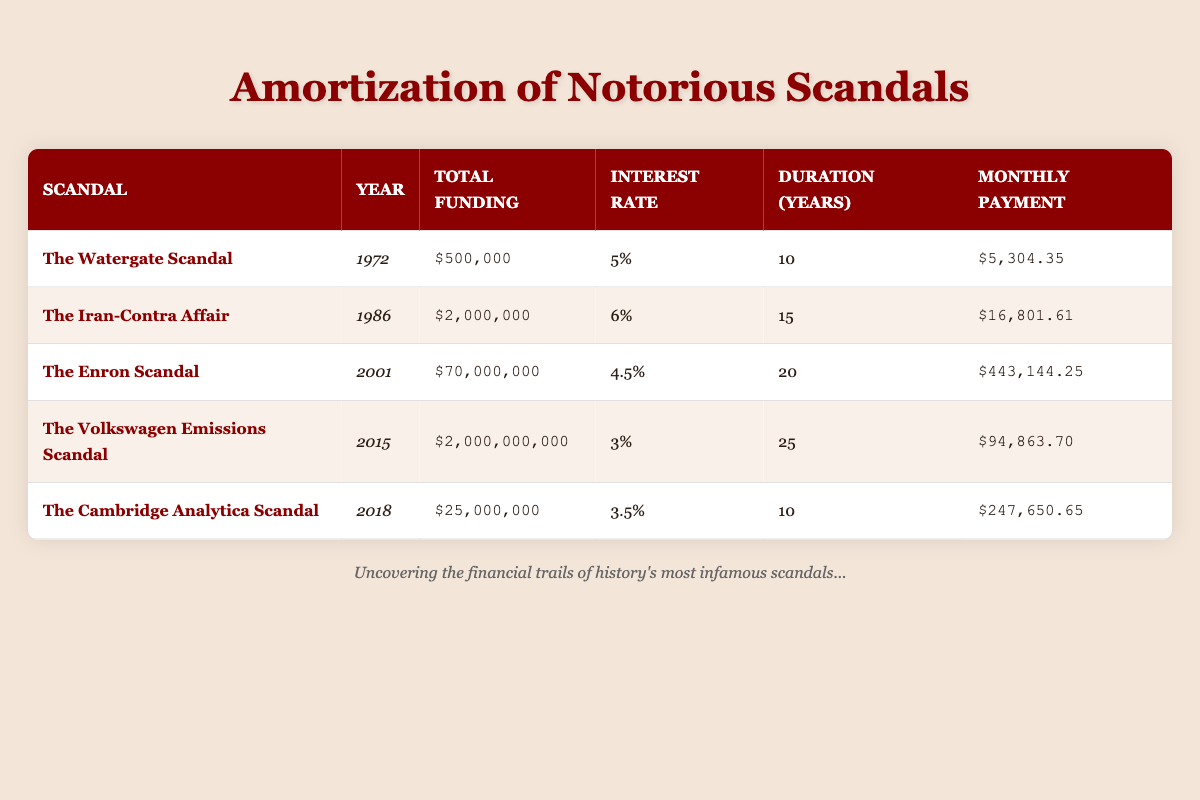What is the total funding for The Iran-Contra Affair? The table lists the total funding for The Iran-Contra Affair under the corresponding column, which shows $2,000,000.
Answer: 2,000,000 What is the interest rate for The Volkswagen Emissions Scandal? Referring to the table, the interest rate for The Volkswagen Emissions Scandal is specified as 3%.
Answer: 3% How much is the monthly payment for the Enron Scandal? The monthly payment listed for the Enron Scandal in the table is $443,144.25.
Answer: 443,144.25 Which scandal had the longest duration for repayment? By comparing the duration columns, The Volkswagen Emissions Scandal had the longest duration for repayment, which is 25 years.
Answer: The Volkswagen Emissions Scandal What is the average total funding of all scandals listed? First, sum the total funding amounts from all scandals: $500,000 + $2,000,000 + $70,000,000 + $2,000,000,000 + $25,000,000 = $2,097,500,000. Then, divide by the number of scandals (5): $2,097,500,000 / 5 = $419,500,000.
Answer: 419,500,000 Is the interest rate for The Cambridge Analytica Scandal higher than 4%? The table shows that the interest rate for The Cambridge Analytica Scandal is 3.5%, which is less than 4%. Thus, the answer is no.
Answer: No What is the difference in monthly payments between The Watergate Scandal and The Iran-Contra Affair? The monthly payment for The Watergate Scandal is $5,304.35, and for The Iran-Contra Affair, it is $16,801.61. To find the difference: $16,801.61 - $5,304.35 = $11,497.26.
Answer: 11,497.26 Which scandal has a total funding greater than $1 billion? The table indicates that The Volkswagen Emissions Scandal has a total funding of $2,000,000,000, exceeding $1 billion.
Answer: Yes How many scandals occurred after the year 2000? The scandals that occurred after 2000 are The Volkswagen Emissions Scandal (2015) and The Cambridge Analytica Scandal (2018), amounting to 2 scandals.
Answer: 2 